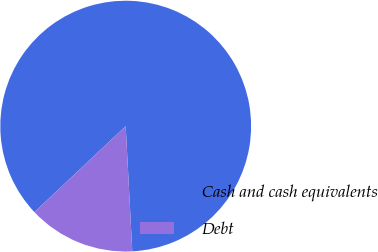Convert chart. <chart><loc_0><loc_0><loc_500><loc_500><pie_chart><fcel>Cash and cash equivalents<fcel>Debt<nl><fcel>86.19%<fcel>13.81%<nl></chart> 